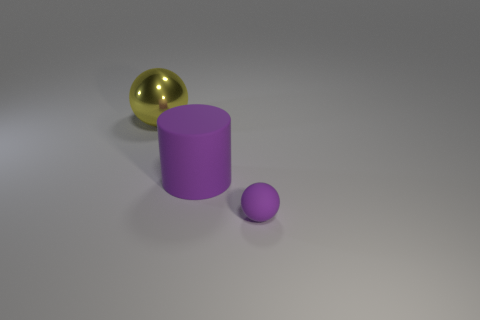Add 3 small brown cylinders. How many objects exist? 6 Add 3 big purple rubber balls. How many big purple rubber balls exist? 3 Subtract 0 green balls. How many objects are left? 3 Subtract all balls. How many objects are left? 1 Subtract all cyan balls. Subtract all gray blocks. How many balls are left? 2 Subtract all small purple rubber balls. Subtract all tiny purple matte things. How many objects are left? 1 Add 2 big balls. How many big balls are left? 3 